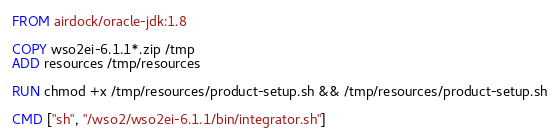<code> <loc_0><loc_0><loc_500><loc_500><_Dockerfile_>FROM airdock/oracle-jdk:1.8

COPY wso2ei-6.1.1*.zip /tmp
ADD resources /tmp/resources

RUN chmod +x /tmp/resources/product-setup.sh && /tmp/resources/product-setup.sh

CMD ["sh", "/wso2/wso2ei-6.1.1/bin/integrator.sh"]</code> 